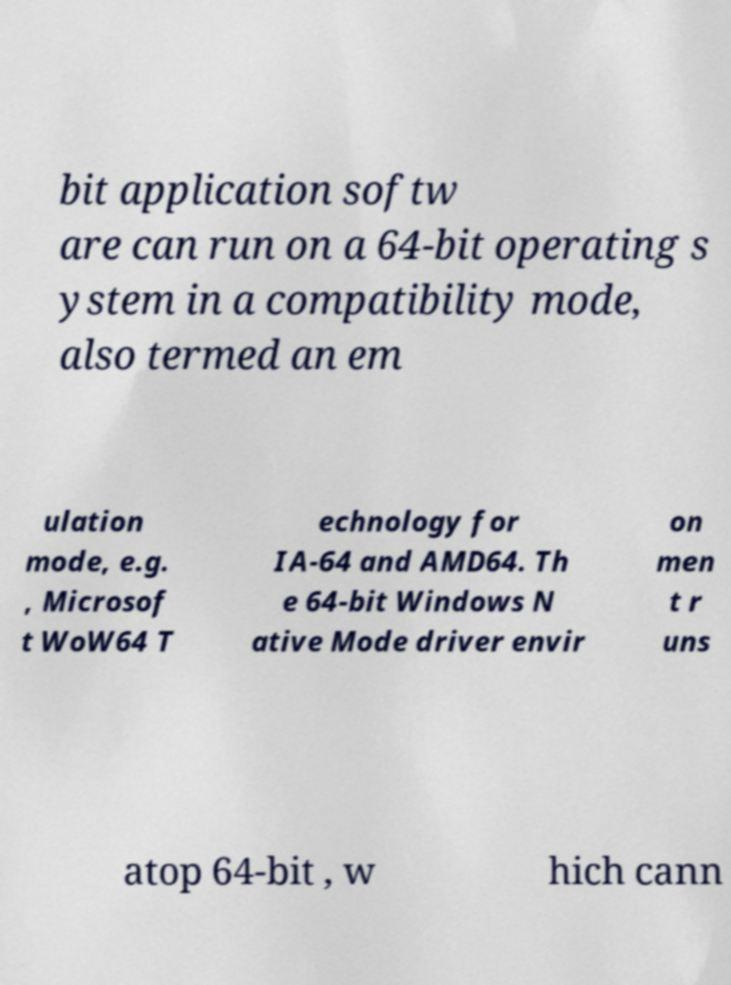Could you extract and type out the text from this image? bit application softw are can run on a 64-bit operating s ystem in a compatibility mode, also termed an em ulation mode, e.g. , Microsof t WoW64 T echnology for IA-64 and AMD64. Th e 64-bit Windows N ative Mode driver envir on men t r uns atop 64-bit , w hich cann 